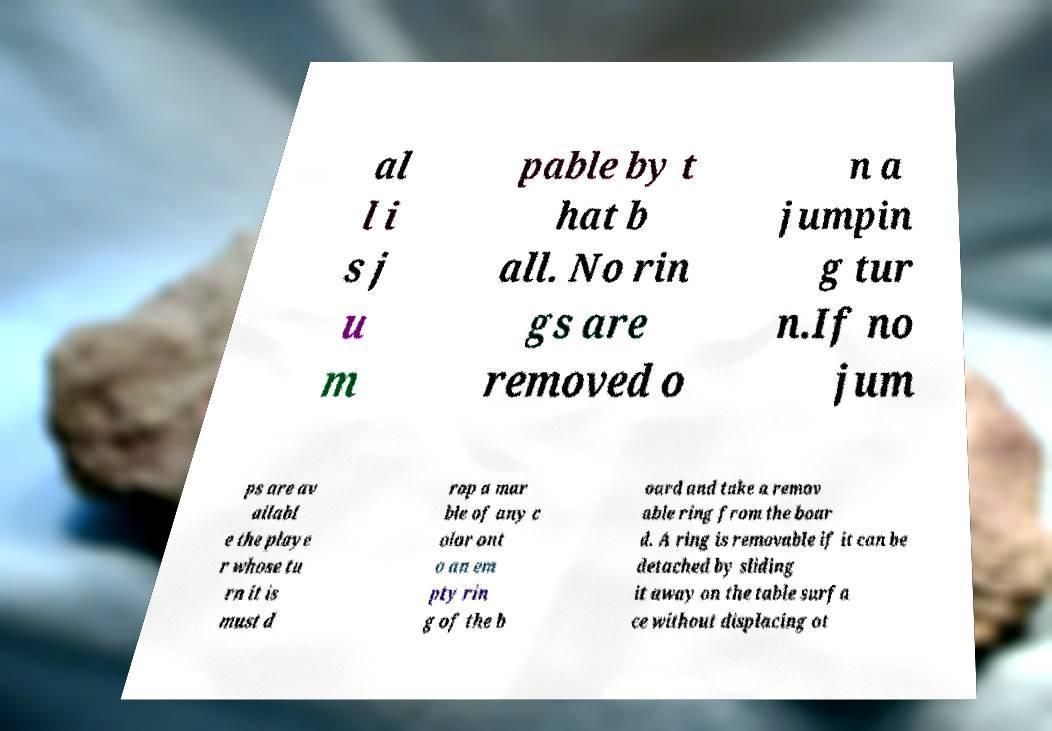What messages or text are displayed in this image? I need them in a readable, typed format. al l i s j u m pable by t hat b all. No rin gs are removed o n a jumpin g tur n.If no jum ps are av ailabl e the playe r whose tu rn it is must d rop a mar ble of any c olor ont o an em pty rin g of the b oard and take a remov able ring from the boar d. A ring is removable if it can be detached by sliding it away on the table surfa ce without displacing ot 